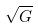<formula> <loc_0><loc_0><loc_500><loc_500>\sqrt { G }</formula> 